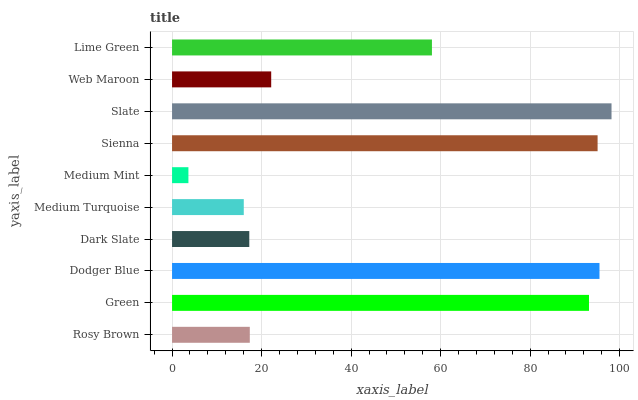Is Medium Mint the minimum?
Answer yes or no. Yes. Is Slate the maximum?
Answer yes or no. Yes. Is Green the minimum?
Answer yes or no. No. Is Green the maximum?
Answer yes or no. No. Is Green greater than Rosy Brown?
Answer yes or no. Yes. Is Rosy Brown less than Green?
Answer yes or no. Yes. Is Rosy Brown greater than Green?
Answer yes or no. No. Is Green less than Rosy Brown?
Answer yes or no. No. Is Lime Green the high median?
Answer yes or no. Yes. Is Web Maroon the low median?
Answer yes or no. Yes. Is Rosy Brown the high median?
Answer yes or no. No. Is Rosy Brown the low median?
Answer yes or no. No. 